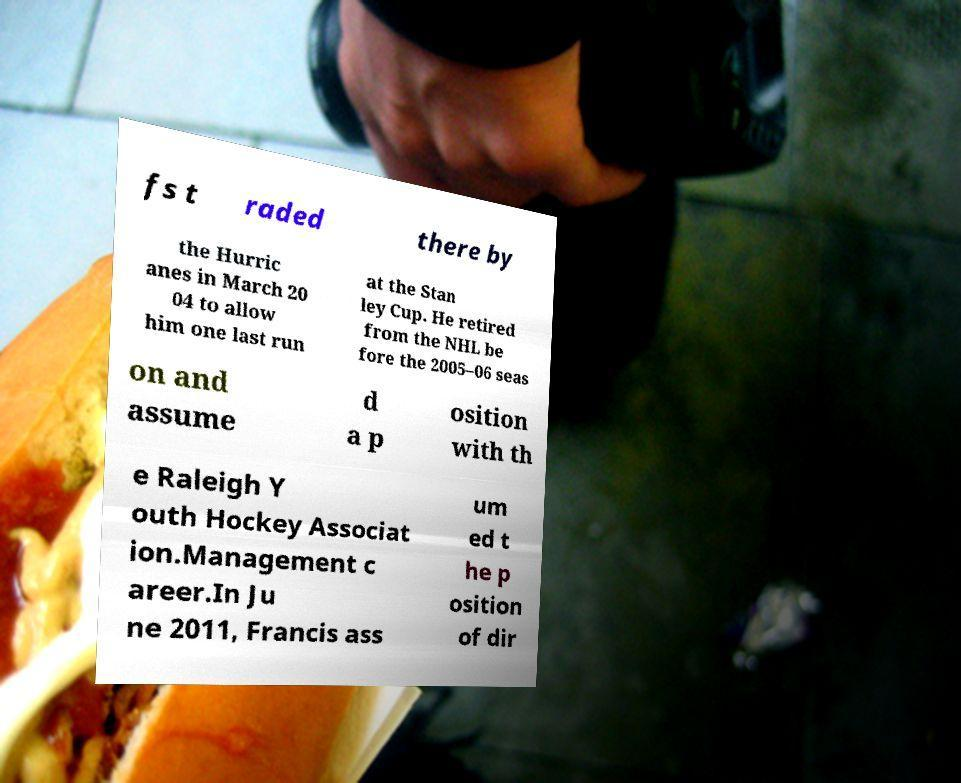Can you accurately transcribe the text from the provided image for me? fs t raded there by the Hurric anes in March 20 04 to allow him one last run at the Stan ley Cup. He retired from the NHL be fore the 2005–06 seas on and assume d a p osition with th e Raleigh Y outh Hockey Associat ion.Management c areer.In Ju ne 2011, Francis ass um ed t he p osition of dir 